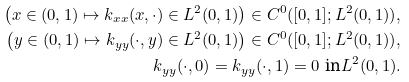Convert formula to latex. <formula><loc_0><loc_0><loc_500><loc_500>\left ( x \in ( 0 , 1 ) \mapsto k _ { x x } ( x , \cdot ) \in L ^ { 2 } ( 0 , 1 ) \right ) \in C ^ { 0 } ( [ 0 , 1 ] ; L ^ { 2 } ( 0 , 1 ) ) , \\ \left ( y \in ( 0 , 1 ) \mapsto k _ { y y } ( \cdot , y ) \in L ^ { 2 } ( 0 , 1 ) \right ) \in C ^ { 0 } ( [ 0 , 1 ] ; L ^ { 2 } ( 0 , 1 ) ) , \\ k _ { y y } ( \cdot , 0 ) = k _ { y y } ( \cdot , 1 ) = 0 \text { in} L ^ { 2 } ( 0 , 1 ) .</formula> 